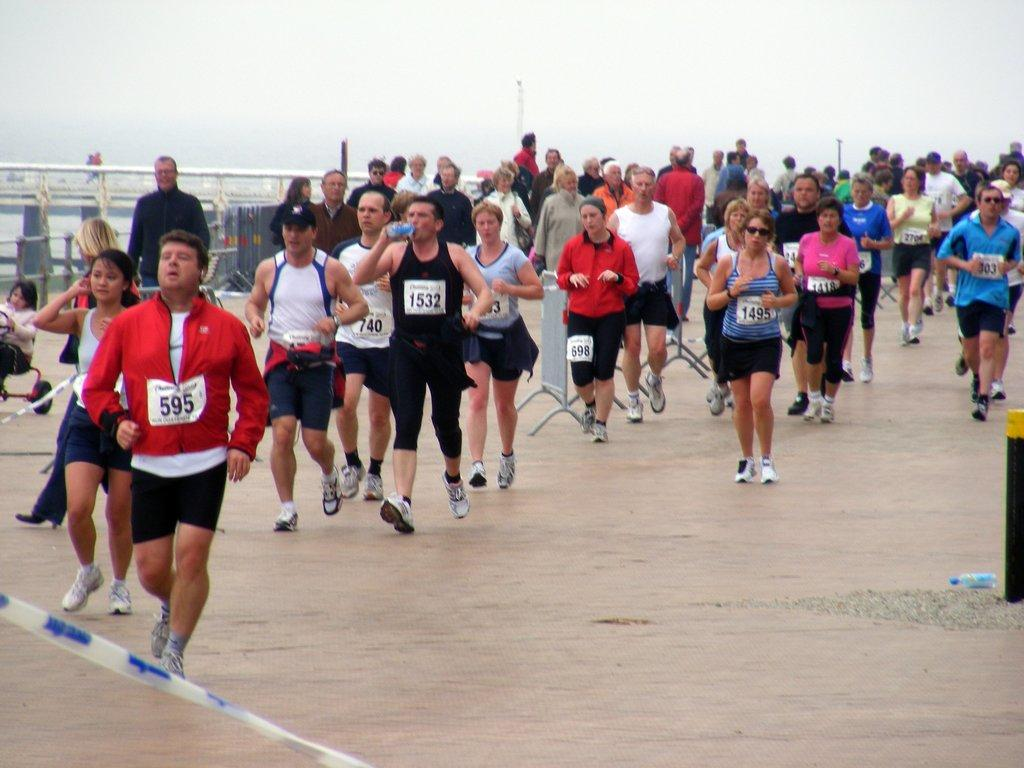What are the people in the image doing? The people in the image are jogging. What type of footwear are the people wearing? The people are wearing shoes. What is the surface on which the people are jogging? There is a floor in the image. What can be seen in the background of the image? In the background, there appears to be a bridge. Reasoning: Let's think step by step by step in order to produce the conversation. We start by identifying the main subjects in the image, which are the people. Then, we describe their actions (jogging) and the type of footwear they are wearing (shoes). Next, we mention the surface they are on (the floor). Finally, we expand the conversation to include the background of the image, which features a bridge. Absurd Question/Answer: How many ants can be seen crawling on the people's shoes in the image? There are no ants visible on the people's shoes in the image. What political party does the representative in the image belong to? There is no representative present in the image. 